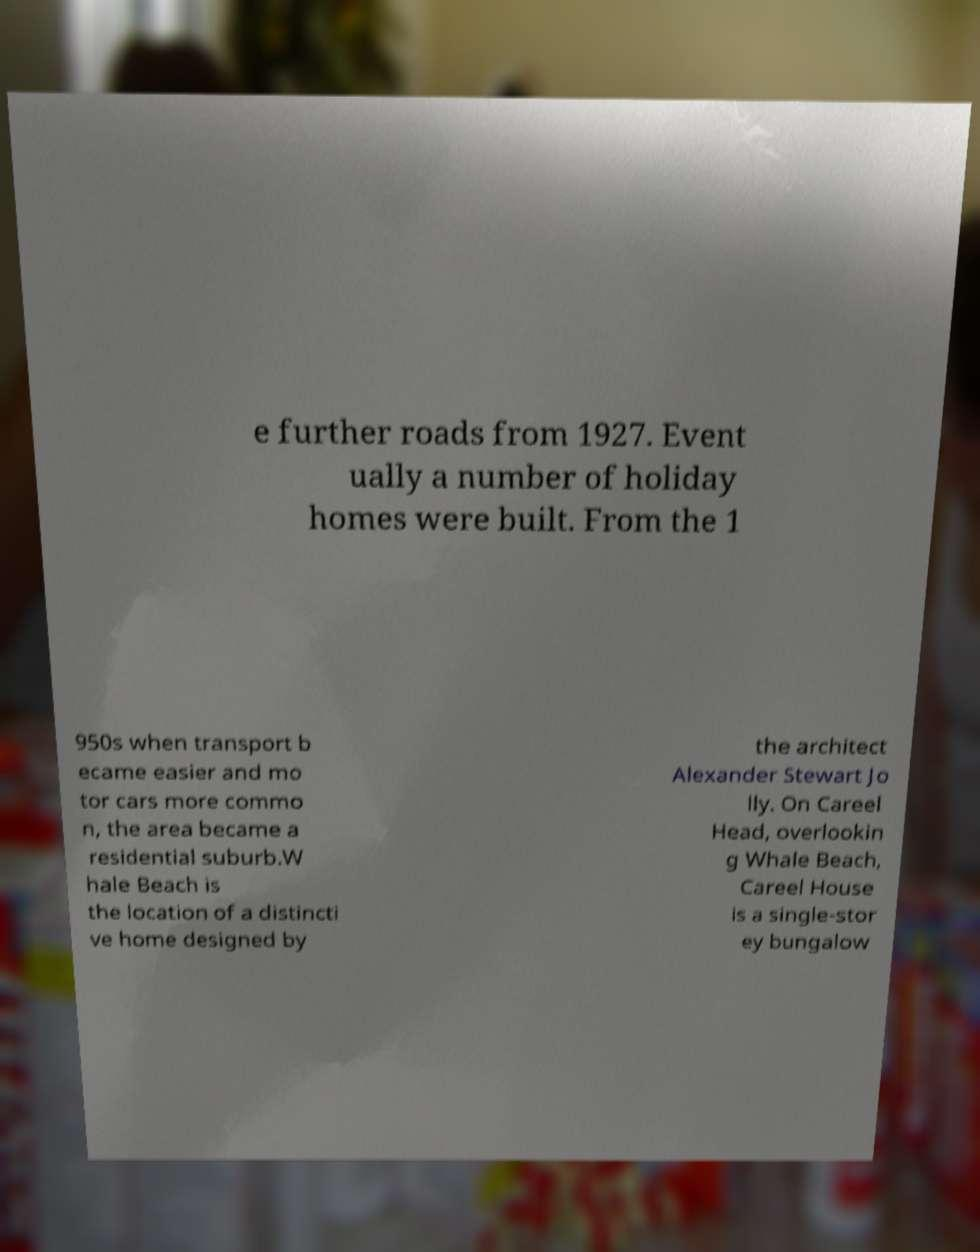Please read and relay the text visible in this image. What does it say? e further roads from 1927. Event ually a number of holiday homes were built. From the 1 950s when transport b ecame easier and mo tor cars more commo n, the area became a residential suburb.W hale Beach is the location of a distincti ve home designed by the architect Alexander Stewart Jo lly. On Careel Head, overlookin g Whale Beach, Careel House is a single-stor ey bungalow 